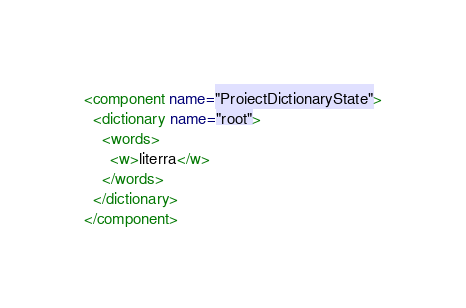<code> <loc_0><loc_0><loc_500><loc_500><_XML_><component name="ProjectDictionaryState">
  <dictionary name="root">
    <words>
      <w>literra</w>
    </words>
  </dictionary>
</component></code> 